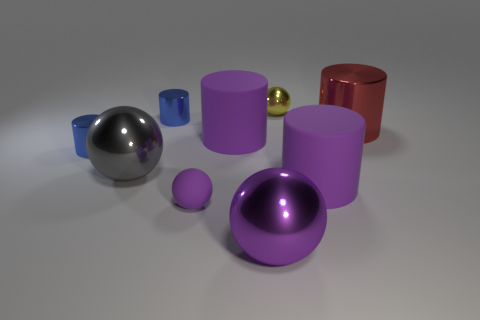What number of other objects are the same shape as the big purple metallic object?
Ensure brevity in your answer.  3. Is there anything else that has the same material as the large purple ball?
Provide a short and direct response. Yes. What is the material of the large gray thing that is the same shape as the tiny purple rubber thing?
Provide a succinct answer. Metal. Is the number of shiny cylinders in front of the small yellow metal thing less than the number of large cyan matte objects?
Ensure brevity in your answer.  No. There is a tiny yellow metallic thing; how many blue cylinders are behind it?
Ensure brevity in your answer.  0. There is a small blue object behind the red metal thing; does it have the same shape as the red metallic object that is in front of the yellow metallic ball?
Provide a succinct answer. Yes. What is the shape of the purple rubber object that is both in front of the big gray ball and on the right side of the small purple ball?
Offer a terse response. Cylinder. What is the size of the purple ball that is the same material as the large red cylinder?
Provide a short and direct response. Large. Are there fewer big shiny cylinders than large blue rubber blocks?
Provide a succinct answer. No. There is a small blue thing behind the small blue shiny thing in front of the large cylinder left of the yellow shiny ball; what is it made of?
Provide a short and direct response. Metal. 